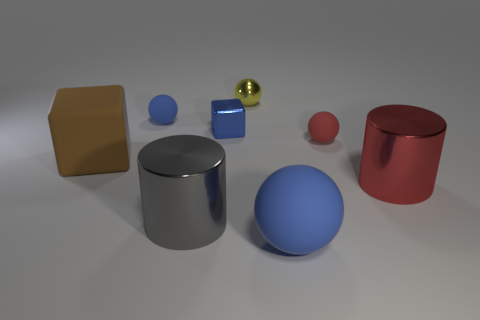Add 2 red cylinders. How many objects exist? 10 Subtract all cylinders. How many objects are left? 6 Add 8 brown metal blocks. How many brown metal blocks exist? 8 Subtract 0 brown cylinders. How many objects are left? 8 Subtract all red things. Subtract all tiny metallic objects. How many objects are left? 4 Add 3 large blue matte spheres. How many large blue matte spheres are left? 4 